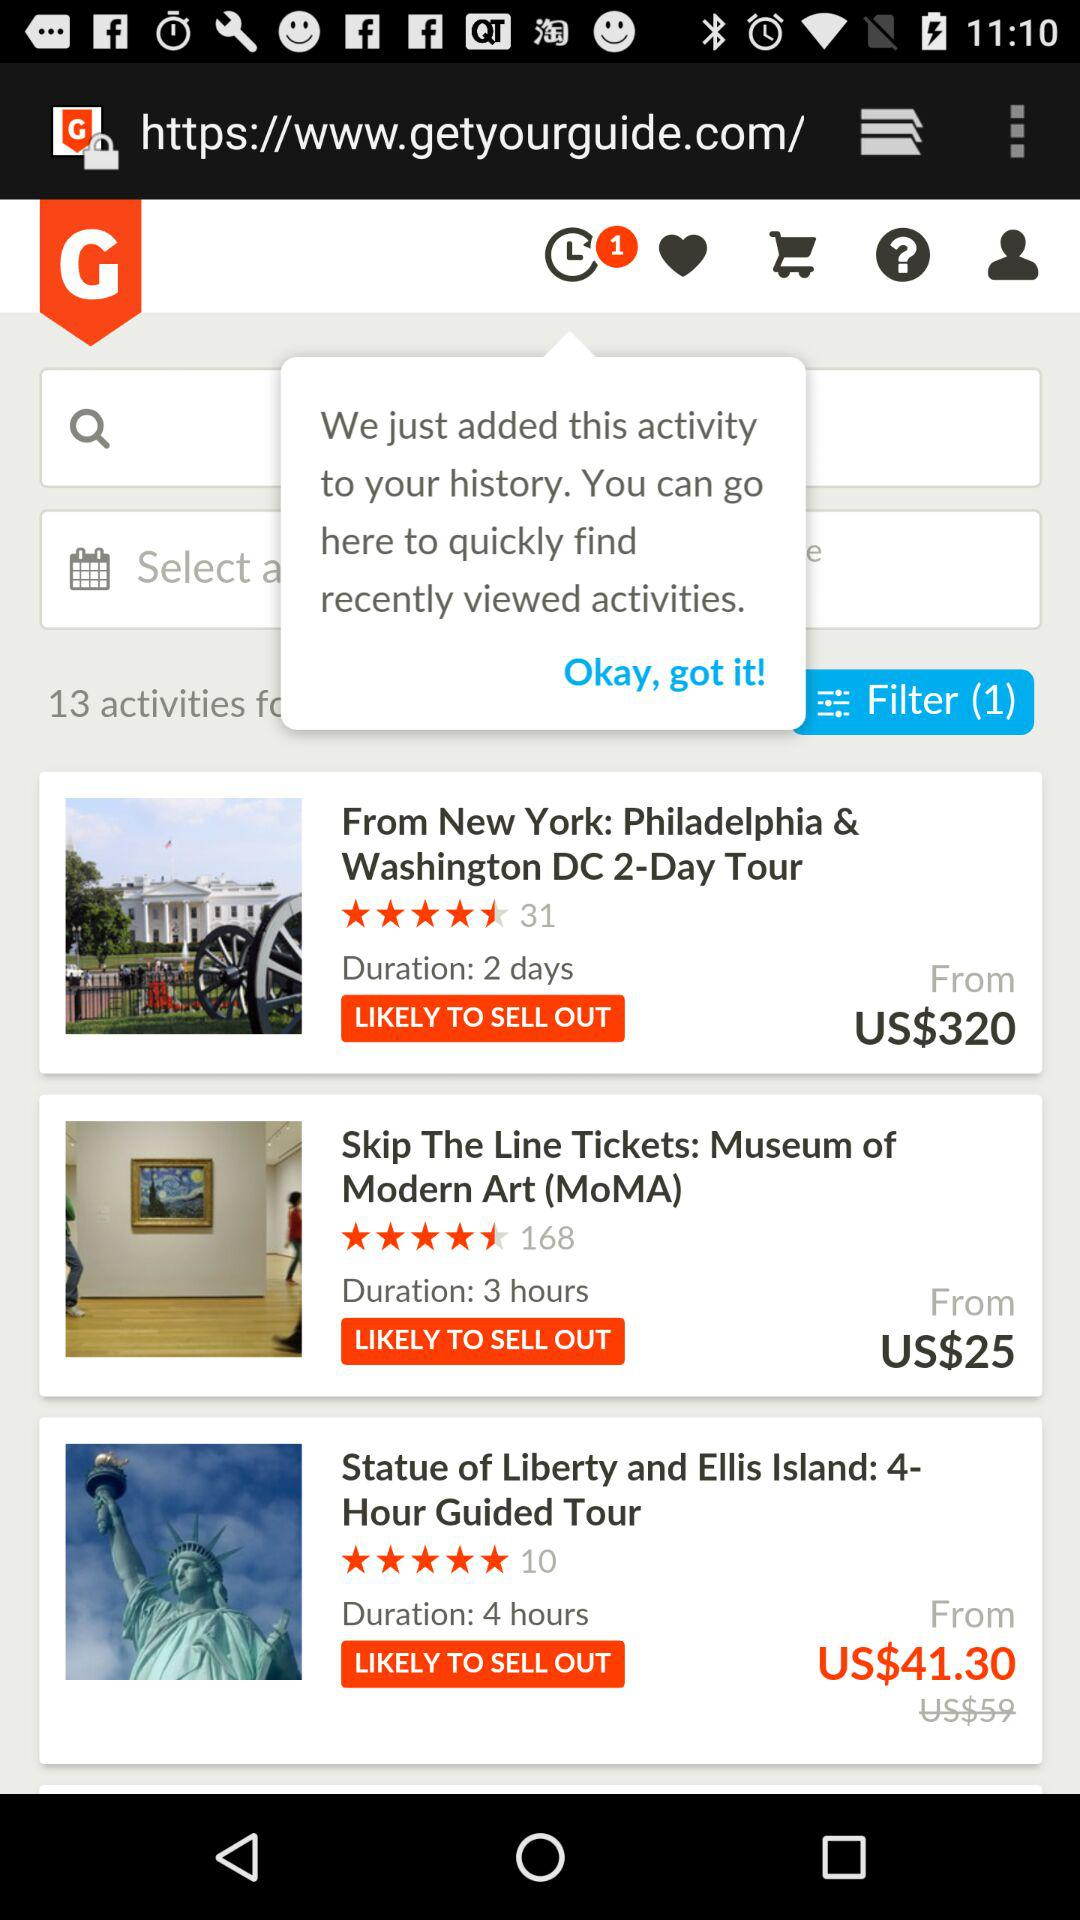How many activities are there? There are 13 activities. 